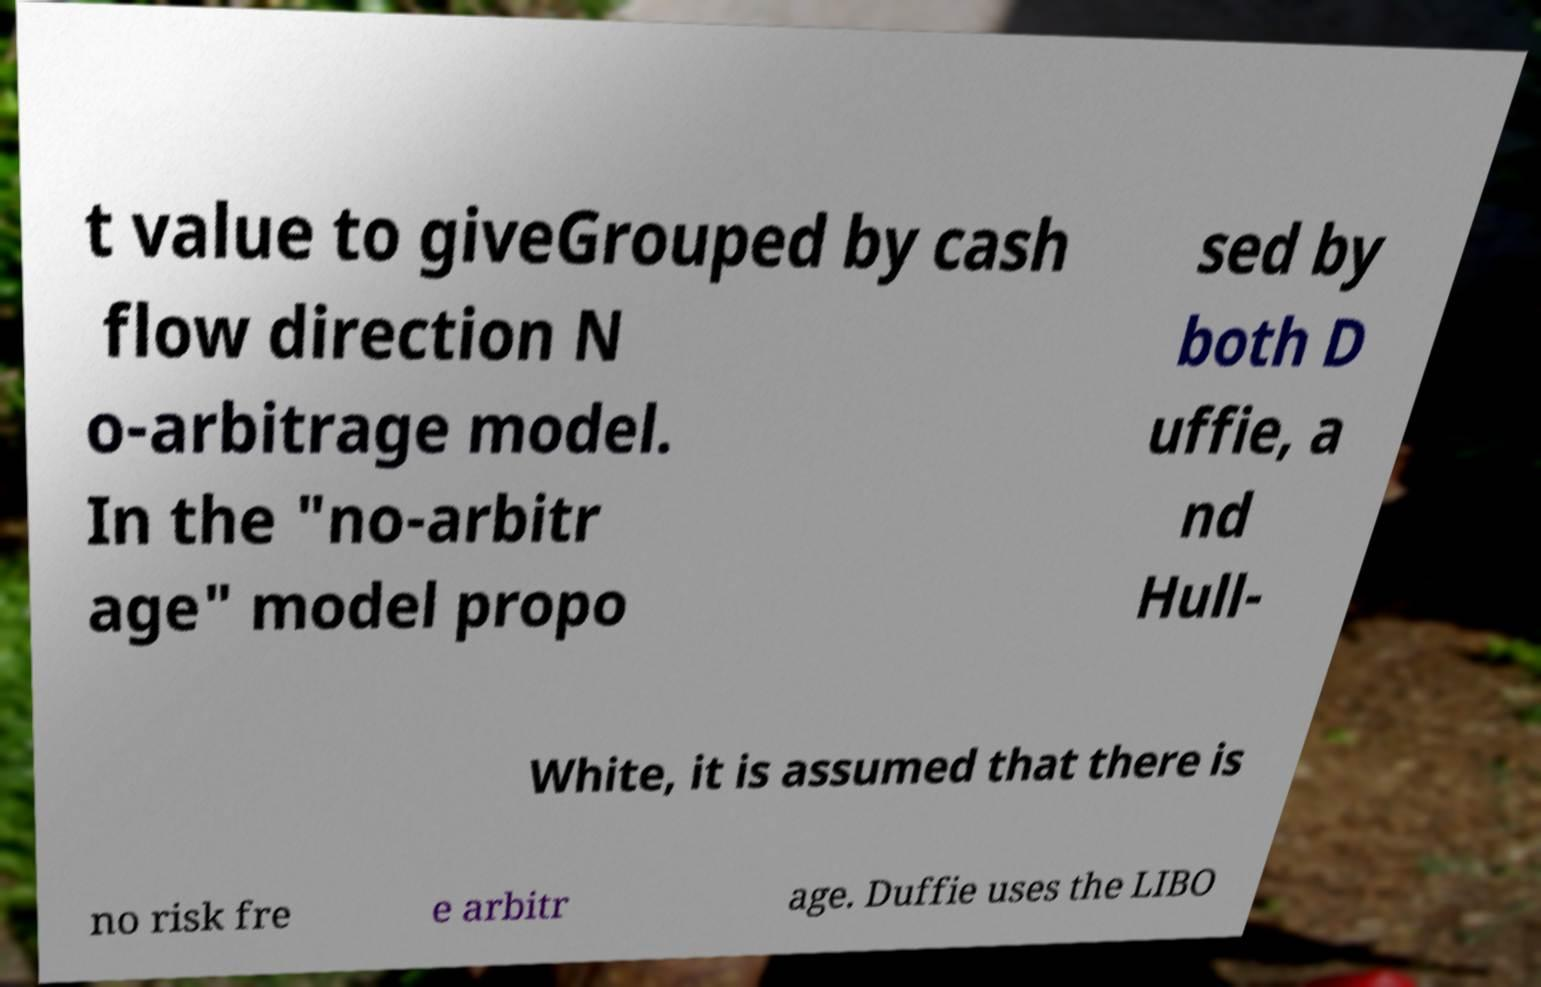What messages or text are displayed in this image? I need them in a readable, typed format. t value to giveGrouped by cash flow direction N o-arbitrage model. In the "no-arbitr age" model propo sed by both D uffie, a nd Hull- White, it is assumed that there is no risk fre e arbitr age. Duffie uses the LIBO 